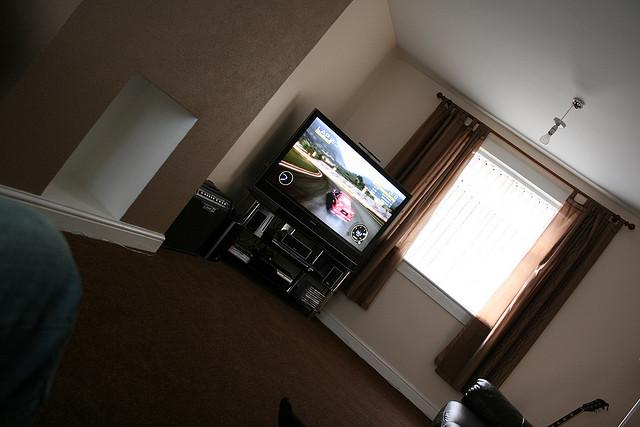What type of game is being played?

Choices:
A) card
B) athletic
C) board
D) video video 